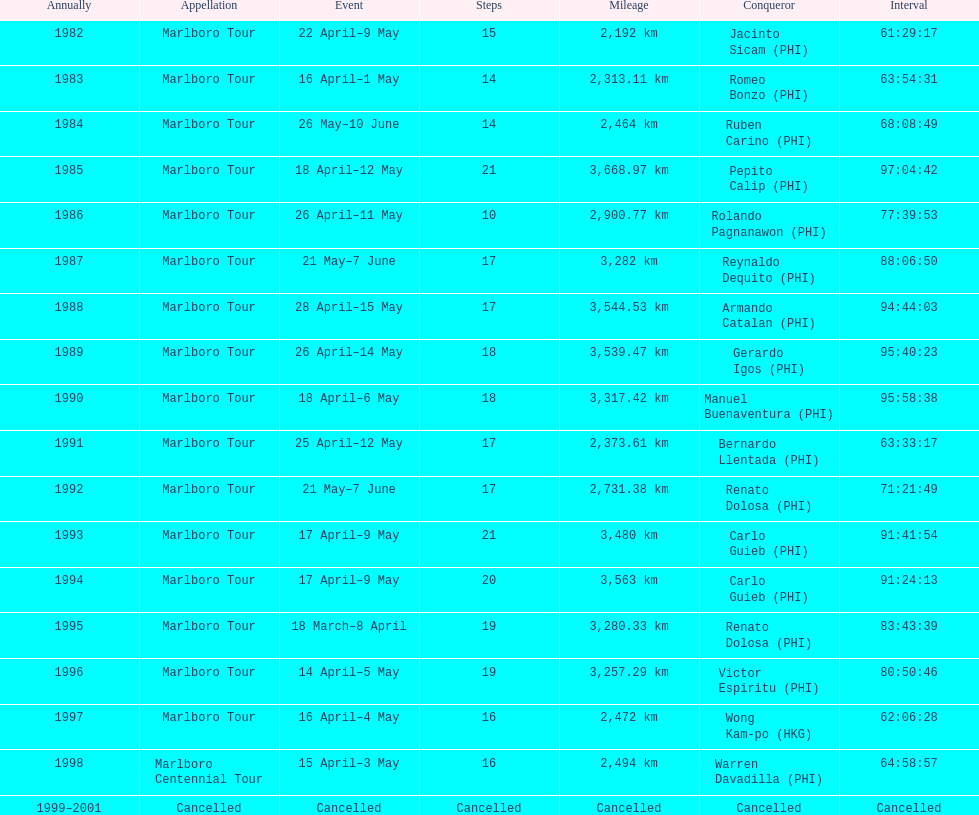Could you help me parse every detail presented in this table? {'header': ['Annually', 'Appellation', 'Event', 'Steps', 'Mileage', 'Conqueror', 'Interval'], 'rows': [['1982', 'Marlboro Tour', '22 April–9 May', '15', '2,192\xa0km', 'Jacinto Sicam\xa0(PHI)', '61:29:17'], ['1983', 'Marlboro Tour', '16 April–1 May', '14', '2,313.11\xa0km', 'Romeo Bonzo\xa0(PHI)', '63:54:31'], ['1984', 'Marlboro Tour', '26 May–10 June', '14', '2,464\xa0km', 'Ruben Carino\xa0(PHI)', '68:08:49'], ['1985', 'Marlboro Tour', '18 April–12 May', '21', '3,668.97\xa0km', 'Pepito Calip\xa0(PHI)', '97:04:42'], ['1986', 'Marlboro Tour', '26 April–11 May', '10', '2,900.77\xa0km', 'Rolando Pagnanawon\xa0(PHI)', '77:39:53'], ['1987', 'Marlboro Tour', '21 May–7 June', '17', '3,282\xa0km', 'Reynaldo Dequito\xa0(PHI)', '88:06:50'], ['1988', 'Marlboro Tour', '28 April–15 May', '17', '3,544.53\xa0km', 'Armando Catalan\xa0(PHI)', '94:44:03'], ['1989', 'Marlboro Tour', '26 April–14 May', '18', '3,539.47\xa0km', 'Gerardo Igos\xa0(PHI)', '95:40:23'], ['1990', 'Marlboro Tour', '18 April–6 May', '18', '3,317.42\xa0km', 'Manuel Buenaventura\xa0(PHI)', '95:58:38'], ['1991', 'Marlboro Tour', '25 April–12 May', '17', '2,373.61\xa0km', 'Bernardo Llentada\xa0(PHI)', '63:33:17'], ['1992', 'Marlboro Tour', '21 May–7 June', '17', '2,731.38\xa0km', 'Renato Dolosa\xa0(PHI)', '71:21:49'], ['1993', 'Marlboro Tour', '17 April–9 May', '21', '3,480\xa0km', 'Carlo Guieb\xa0(PHI)', '91:41:54'], ['1994', 'Marlboro Tour', '17 April–9 May', '20', '3,563\xa0km', 'Carlo Guieb\xa0(PHI)', '91:24:13'], ['1995', 'Marlboro Tour', '18 March–8 April', '19', '3,280.33\xa0km', 'Renato Dolosa\xa0(PHI)', '83:43:39'], ['1996', 'Marlboro Tour', '14 April–5 May', '19', '3,257.29\xa0km', 'Victor Espiritu\xa0(PHI)', '80:50:46'], ['1997', 'Marlboro Tour', '16 April–4 May', '16', '2,472\xa0km', 'Wong Kam-po\xa0(HKG)', '62:06:28'], ['1998', 'Marlboro Centennial Tour', '15 April–3 May', '16', '2,494\xa0km', 'Warren Davadilla\xa0(PHI)', '64:58:57'], ['1999–2001', 'Cancelled', 'Cancelled', 'Cancelled', 'Cancelled', 'Cancelled', 'Cancelled']]} How many stages was the 1982 marlboro tour? 15. 